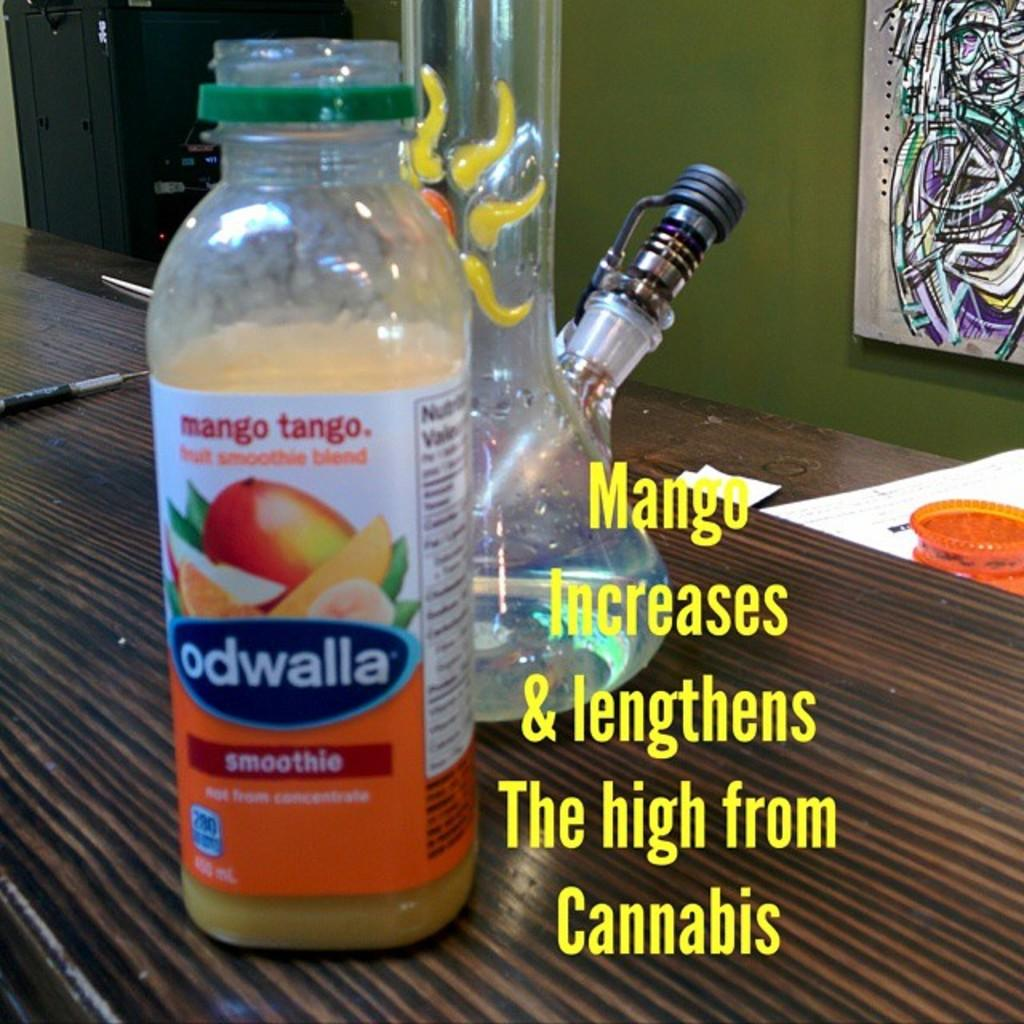Provide a one-sentence caption for the provided image. A bottle of Odwalla smoothie on a table next to a drinking glass. 